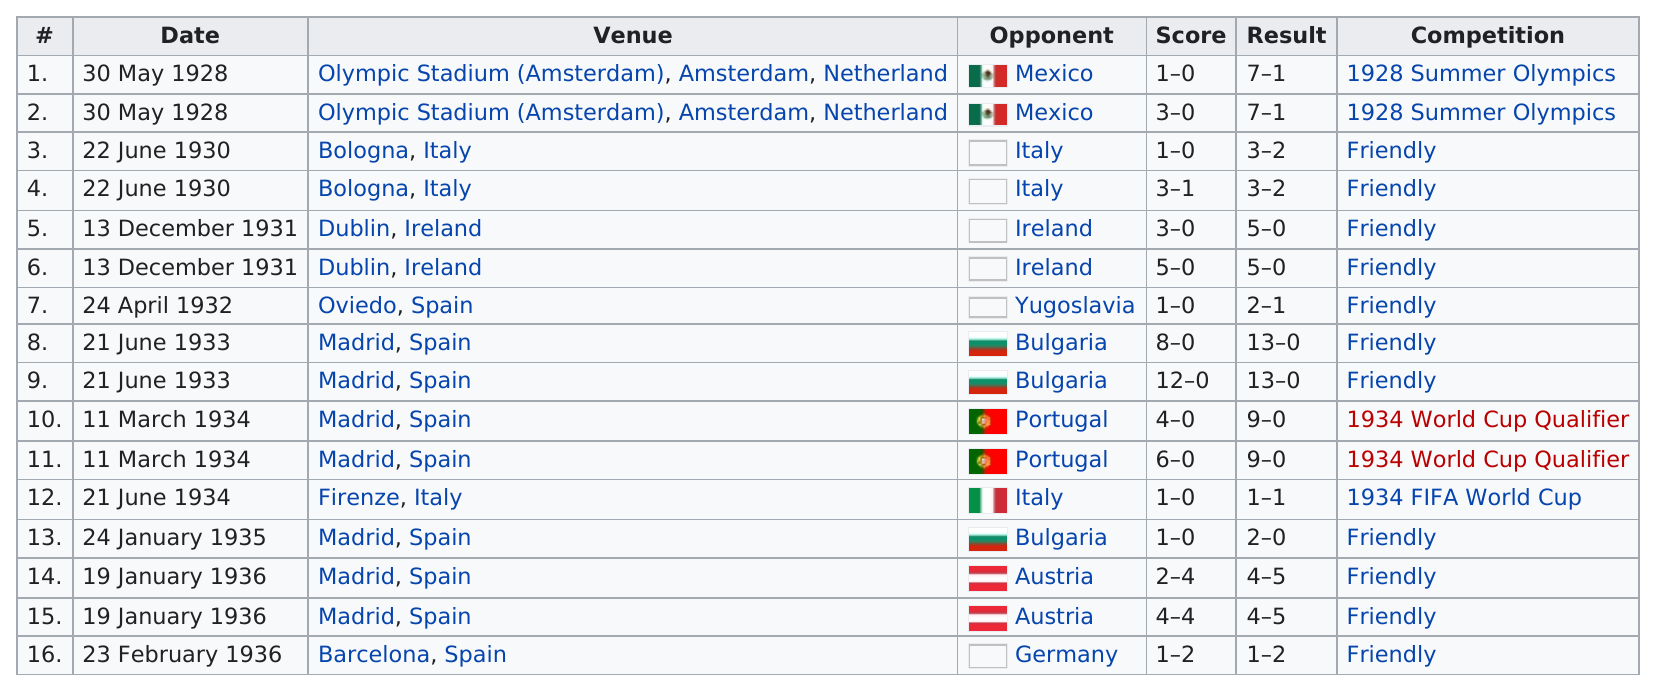Identify some key points in this picture. The Madrid, Spain venue was used a total of 7 times. The most number of points scored in a game was 12. Spain played against Bulgaria before facing off against Portugal in a previous match. The Olympic Stadium in the Netherlands is located in Amsterdam. Madrid, Spain hosted the largest number of events within the table. 